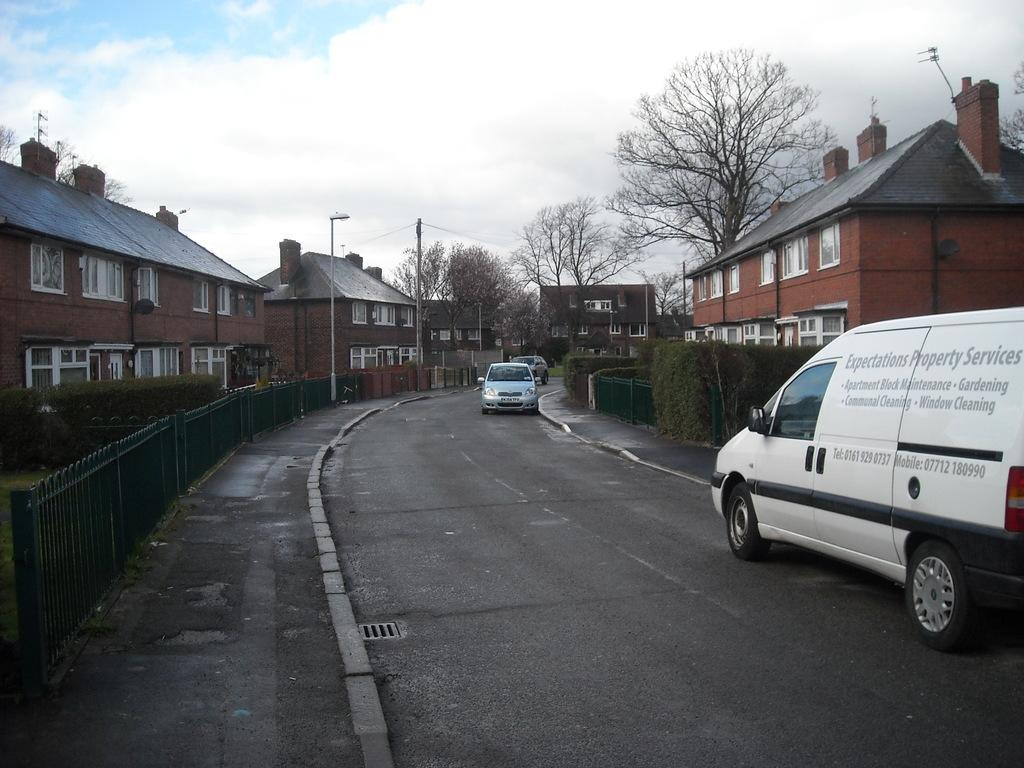Provide a one-sentence caption for the provided image. A van from Expectations Property Services is parked on a residential street. 